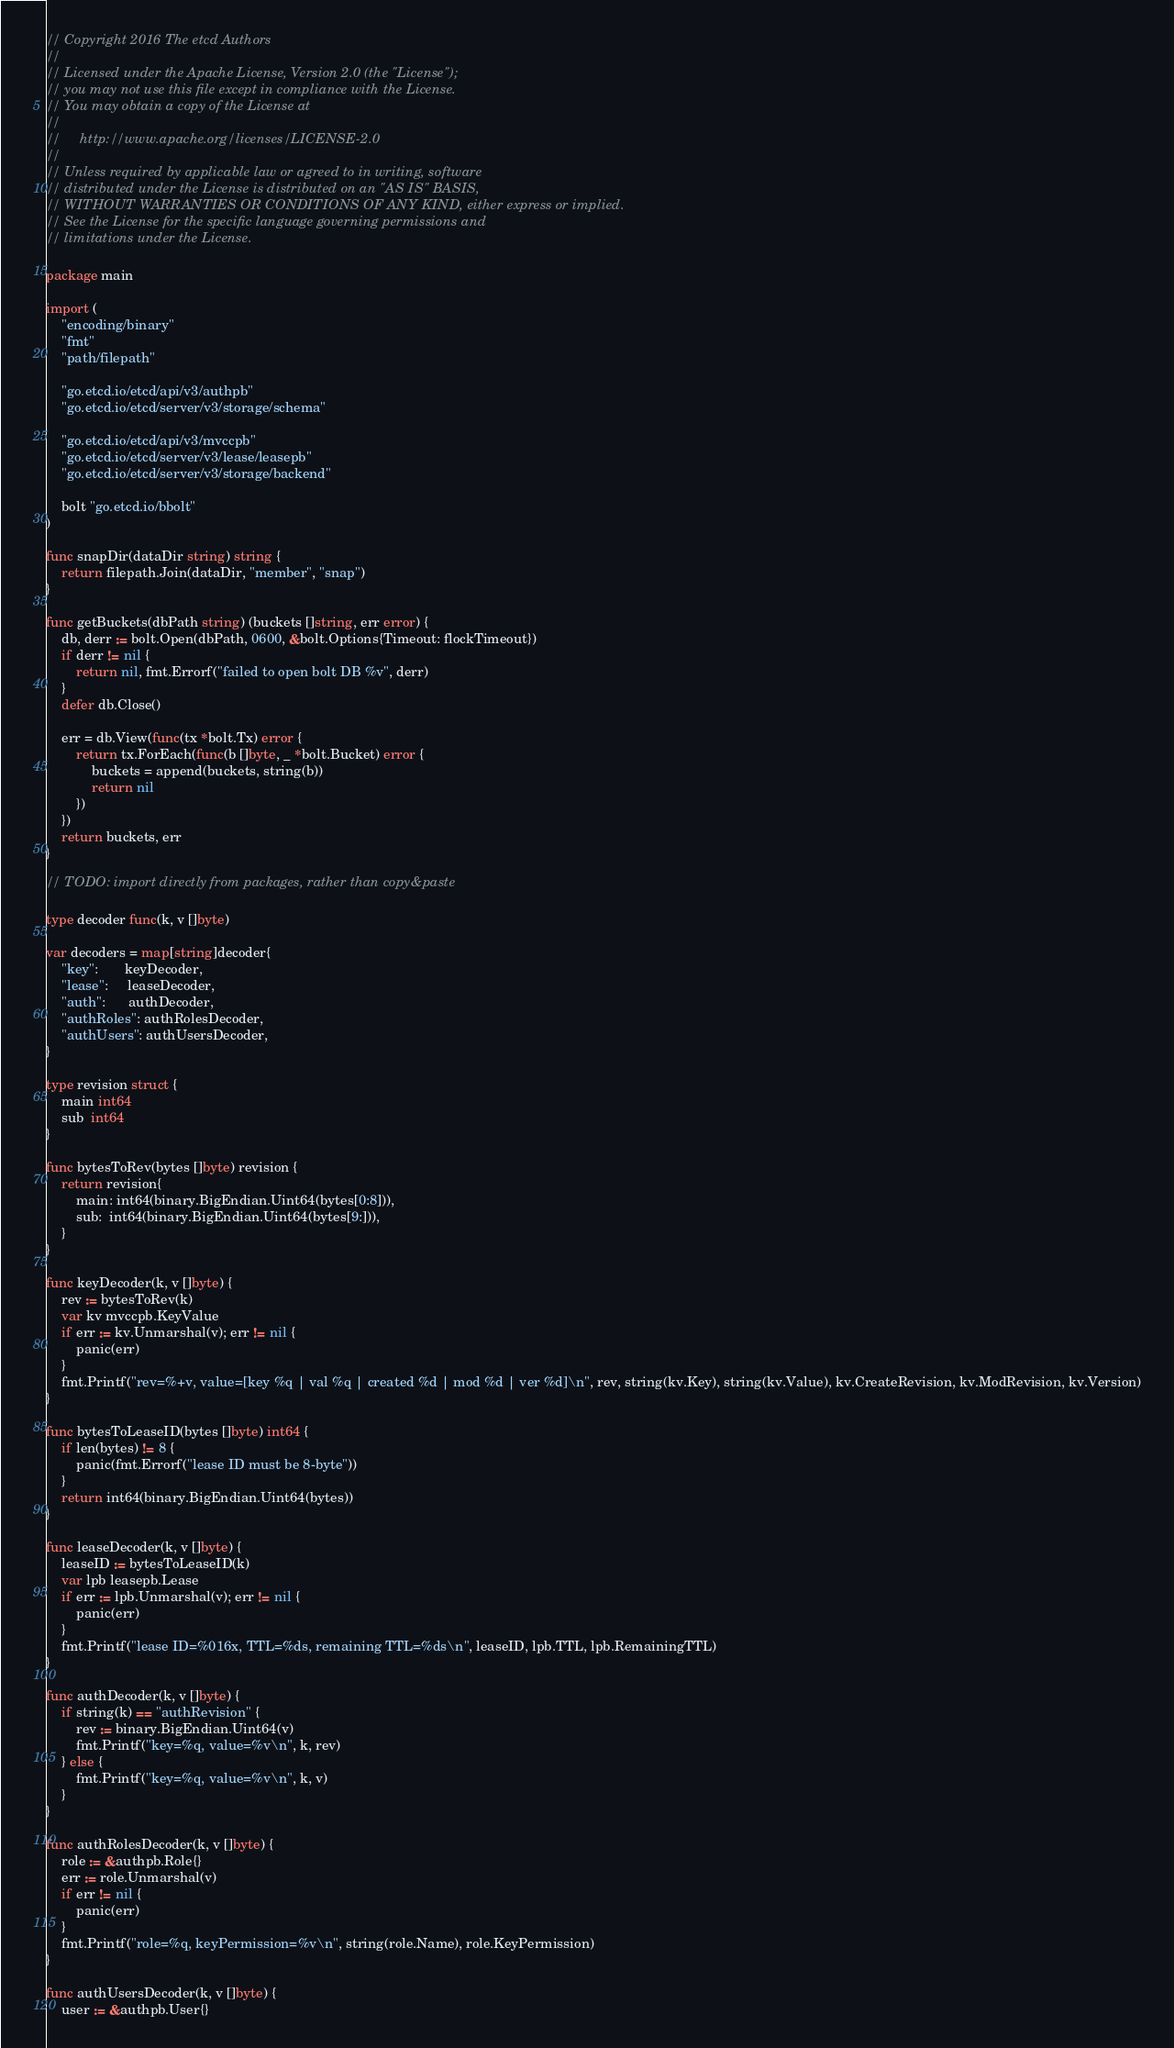<code> <loc_0><loc_0><loc_500><loc_500><_Go_>// Copyright 2016 The etcd Authors
//
// Licensed under the Apache License, Version 2.0 (the "License");
// you may not use this file except in compliance with the License.
// You may obtain a copy of the License at
//
//     http://www.apache.org/licenses/LICENSE-2.0
//
// Unless required by applicable law or agreed to in writing, software
// distributed under the License is distributed on an "AS IS" BASIS,
// WITHOUT WARRANTIES OR CONDITIONS OF ANY KIND, either express or implied.
// See the License for the specific language governing permissions and
// limitations under the License.

package main

import (
	"encoding/binary"
	"fmt"
	"path/filepath"

	"go.etcd.io/etcd/api/v3/authpb"
	"go.etcd.io/etcd/server/v3/storage/schema"

	"go.etcd.io/etcd/api/v3/mvccpb"
	"go.etcd.io/etcd/server/v3/lease/leasepb"
	"go.etcd.io/etcd/server/v3/storage/backend"

	bolt "go.etcd.io/bbolt"
)

func snapDir(dataDir string) string {
	return filepath.Join(dataDir, "member", "snap")
}

func getBuckets(dbPath string) (buckets []string, err error) {
	db, derr := bolt.Open(dbPath, 0600, &bolt.Options{Timeout: flockTimeout})
	if derr != nil {
		return nil, fmt.Errorf("failed to open bolt DB %v", derr)
	}
	defer db.Close()

	err = db.View(func(tx *bolt.Tx) error {
		return tx.ForEach(func(b []byte, _ *bolt.Bucket) error {
			buckets = append(buckets, string(b))
			return nil
		})
	})
	return buckets, err
}

// TODO: import directly from packages, rather than copy&paste

type decoder func(k, v []byte)

var decoders = map[string]decoder{
	"key":       keyDecoder,
	"lease":     leaseDecoder,
	"auth":      authDecoder,
	"authRoles": authRolesDecoder,
	"authUsers": authUsersDecoder,
}

type revision struct {
	main int64
	sub  int64
}

func bytesToRev(bytes []byte) revision {
	return revision{
		main: int64(binary.BigEndian.Uint64(bytes[0:8])),
		sub:  int64(binary.BigEndian.Uint64(bytes[9:])),
	}
}

func keyDecoder(k, v []byte) {
	rev := bytesToRev(k)
	var kv mvccpb.KeyValue
	if err := kv.Unmarshal(v); err != nil {
		panic(err)
	}
	fmt.Printf("rev=%+v, value=[key %q | val %q | created %d | mod %d | ver %d]\n", rev, string(kv.Key), string(kv.Value), kv.CreateRevision, kv.ModRevision, kv.Version)
}

func bytesToLeaseID(bytes []byte) int64 {
	if len(bytes) != 8 {
		panic(fmt.Errorf("lease ID must be 8-byte"))
	}
	return int64(binary.BigEndian.Uint64(bytes))
}

func leaseDecoder(k, v []byte) {
	leaseID := bytesToLeaseID(k)
	var lpb leasepb.Lease
	if err := lpb.Unmarshal(v); err != nil {
		panic(err)
	}
	fmt.Printf("lease ID=%016x, TTL=%ds, remaining TTL=%ds\n", leaseID, lpb.TTL, lpb.RemainingTTL)
}

func authDecoder(k, v []byte) {
	if string(k) == "authRevision" {
		rev := binary.BigEndian.Uint64(v)
		fmt.Printf("key=%q, value=%v\n", k, rev)
	} else {
		fmt.Printf("key=%q, value=%v\n", k, v)
	}
}

func authRolesDecoder(k, v []byte) {
	role := &authpb.Role{}
	err := role.Unmarshal(v)
	if err != nil {
		panic(err)
	}
	fmt.Printf("role=%q, keyPermission=%v\n", string(role.Name), role.KeyPermission)
}

func authUsersDecoder(k, v []byte) {
	user := &authpb.User{}</code> 